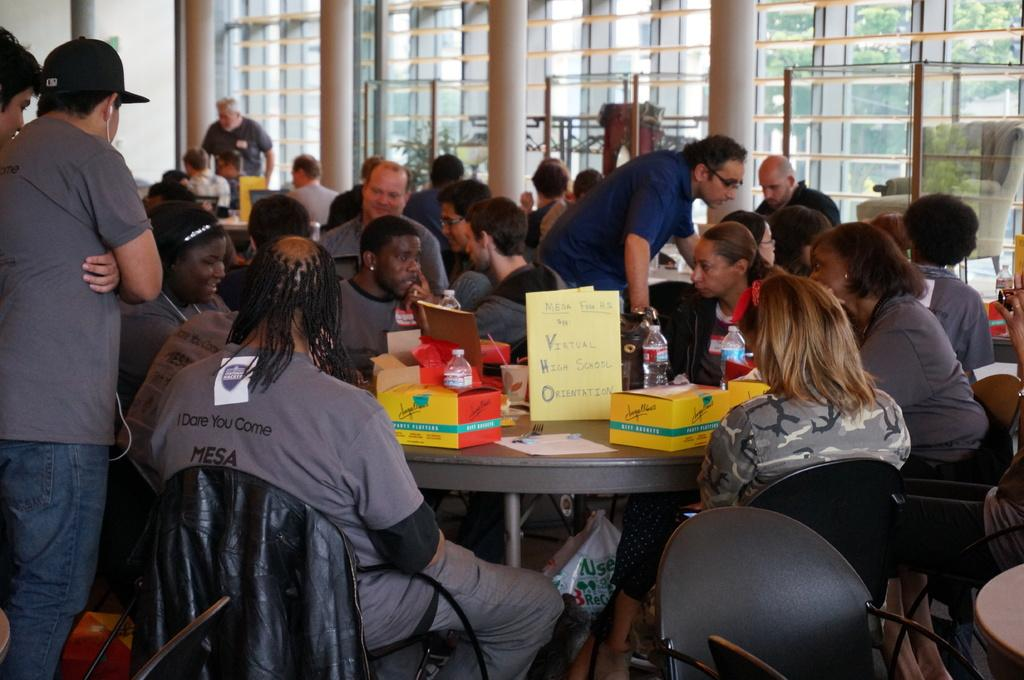What is the color of the wall in the image? The wall in the image is white. What can be seen on the wall in the image? There is a window on the wall in the image. What are the people in the image doing? The people in the image are standing and sitting on chairs. What furniture is present in the image? There is a table in the image. What objects are on the table in the image? There is a box, a paper, a poster, and a bottle on the table in the image. Can you describe the face of the person standing behind the wall in the image? There is no person standing behind the wall in the image. 